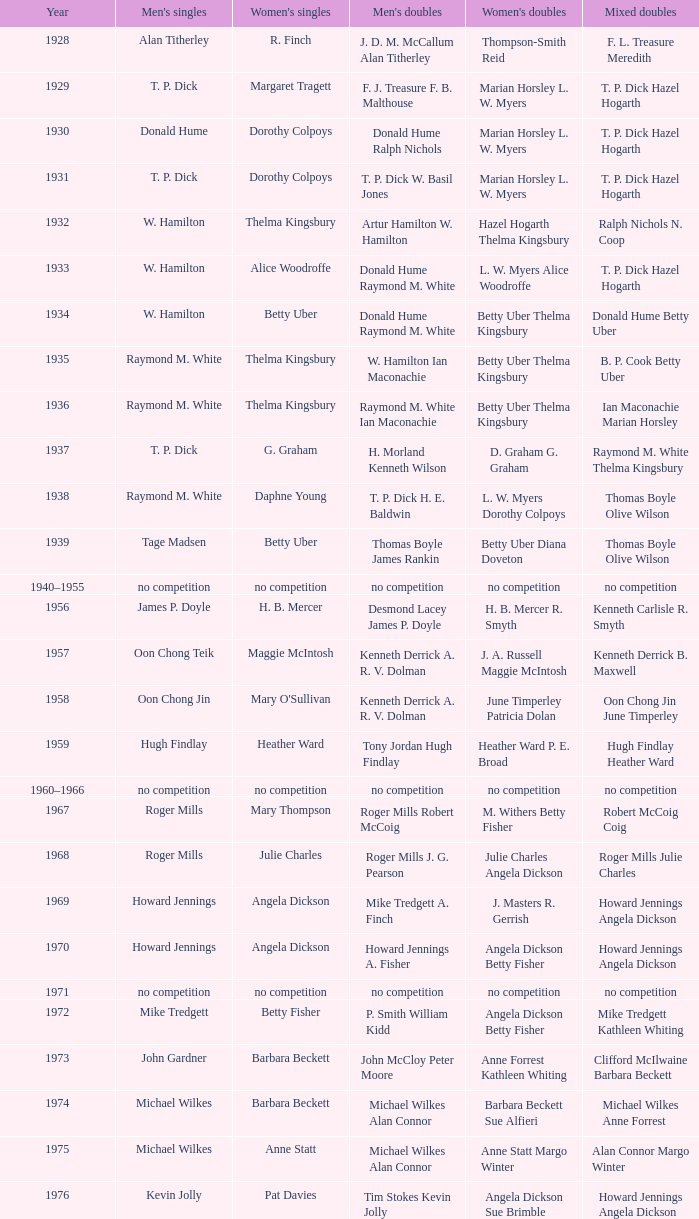Who won the Women's doubles in the year that Billy Gilliland Karen Puttick won the Mixed doubles? Jane Webster Karen Puttick. 